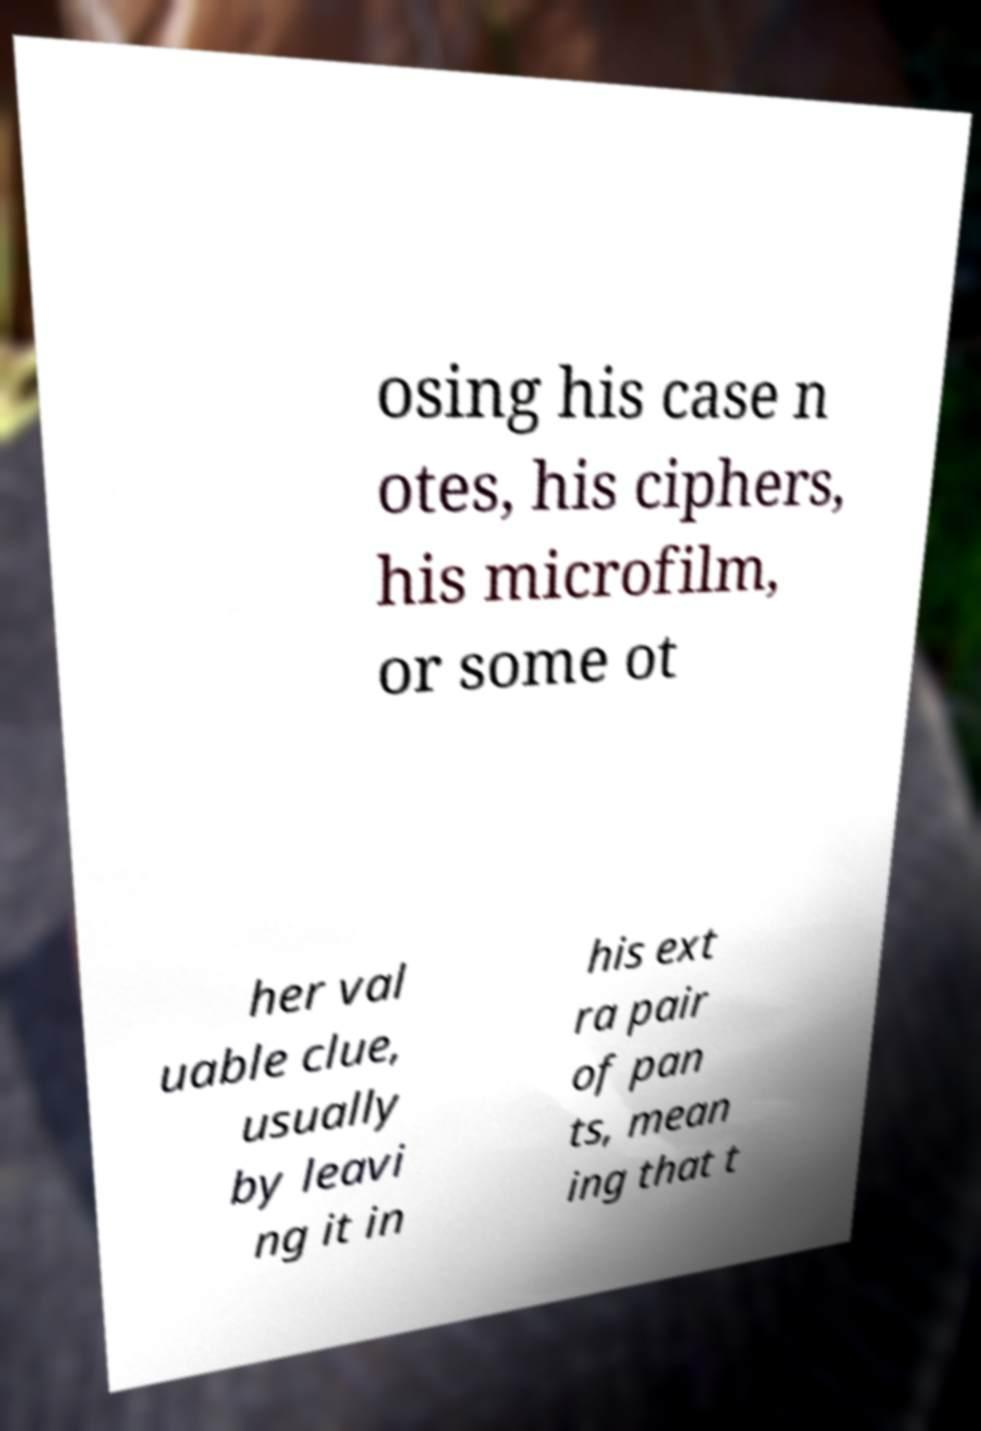Could you extract and type out the text from this image? osing his case n otes, his ciphers, his microfilm, or some ot her val uable clue, usually by leavi ng it in his ext ra pair of pan ts, mean ing that t 